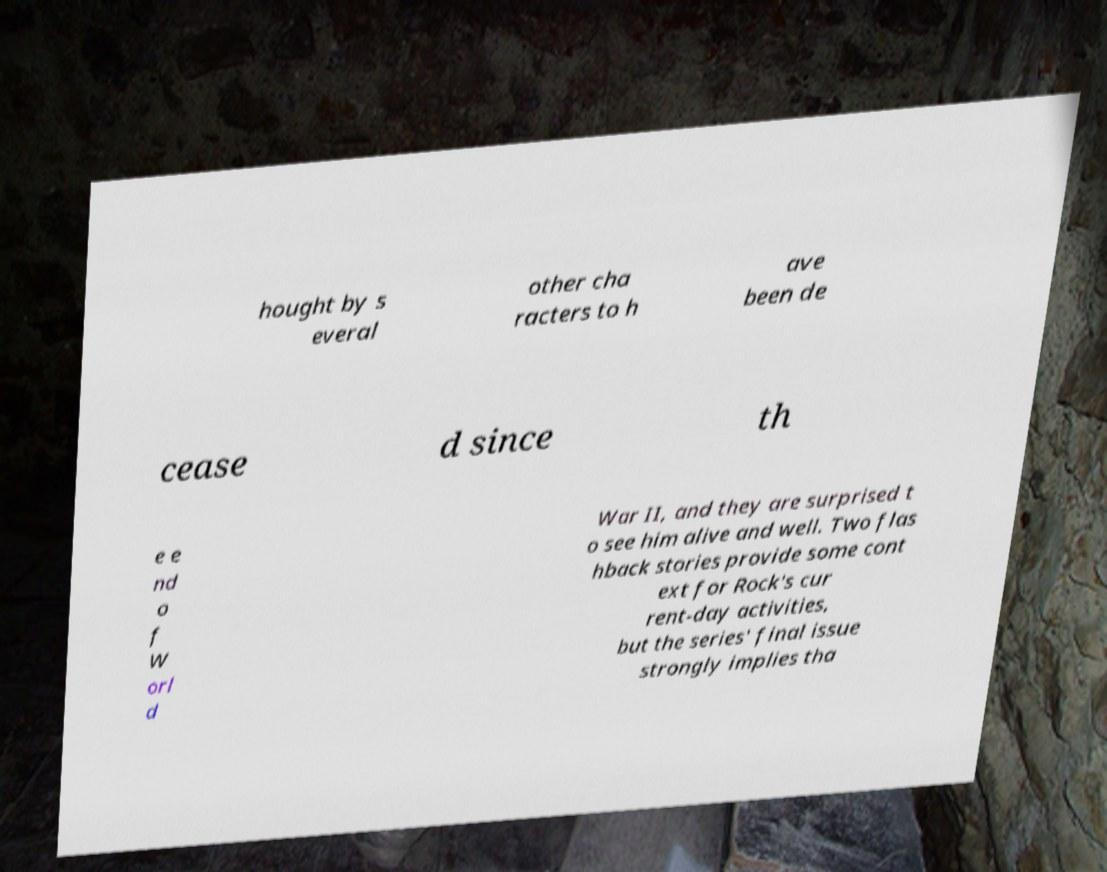For documentation purposes, I need the text within this image transcribed. Could you provide that? hought by s everal other cha racters to h ave been de cease d since th e e nd o f W orl d War II, and they are surprised t o see him alive and well. Two flas hback stories provide some cont ext for Rock's cur rent-day activities, but the series' final issue strongly implies tha 